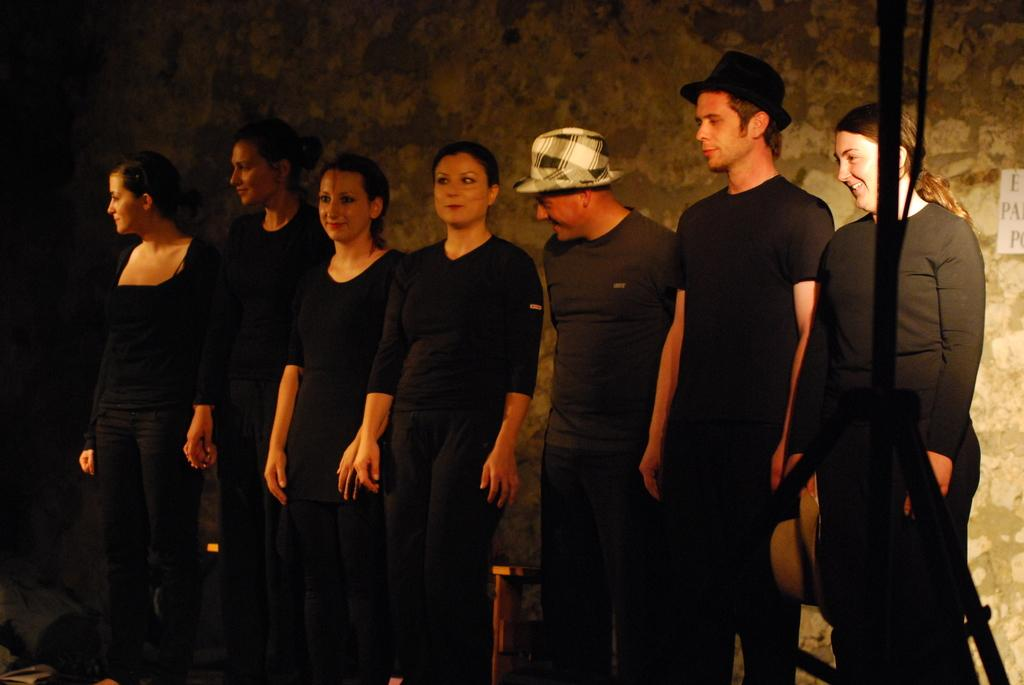Who or what can be seen in the image? There are people in the image. What are the people wearing? The people are wearing black dresses. What are the people doing in the image? The people are standing. What can be seen in the background of the image? There is a wall in the background of the image. What type of flower can be seen growing out of the mouth of one of the people in the image? There is no flower or mouth visible in the image; the people are wearing black dresses and standing. 